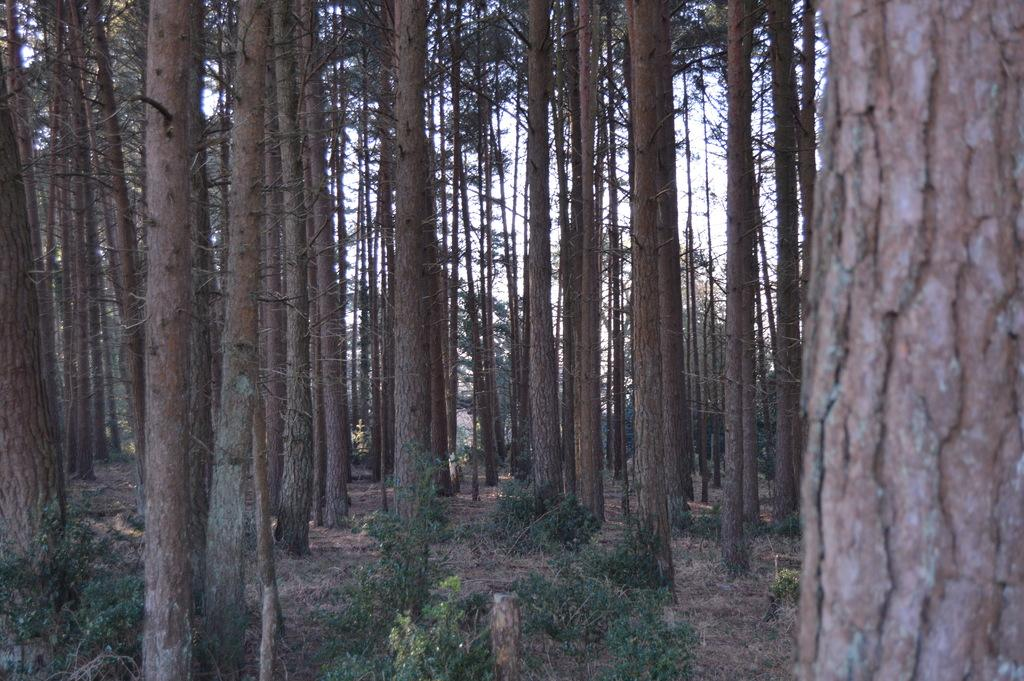What type of living organisms can be seen in the image? Plants and trees are visible in the image. Can you describe the natural setting visible in the image? The natural setting includes plants, trees, and the sky visible in the background. What is the name of the book that is being written in the image? There is no book or writing present in the image; it features plants and trees. What word is being used to describe the plants in the image? There is no specific word being used to describe the plants in the image, as it simply shows plants and trees. 